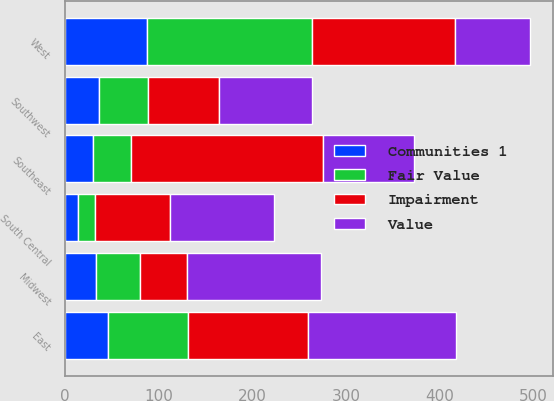<chart> <loc_0><loc_0><loc_500><loc_500><stacked_bar_chart><ecel><fcel>East<fcel>Midwest<fcel>Southeast<fcel>South Central<fcel>Southwest<fcel>West<nl><fcel>Impairment<fcel>129<fcel>50<fcel>205<fcel>80.05<fcel>75<fcel>152<nl><fcel>Value<fcel>157.8<fcel>143<fcel>97.5<fcel>110.8<fcel>99.7<fcel>80.05<nl><fcel>Fair Value<fcel>85.1<fcel>47.8<fcel>40.9<fcel>17.7<fcel>53<fcel>176.8<nl><fcel>Communities 1<fcel>45.9<fcel>32.8<fcel>29.8<fcel>14.2<fcel>36.2<fcel>87.5<nl></chart> 